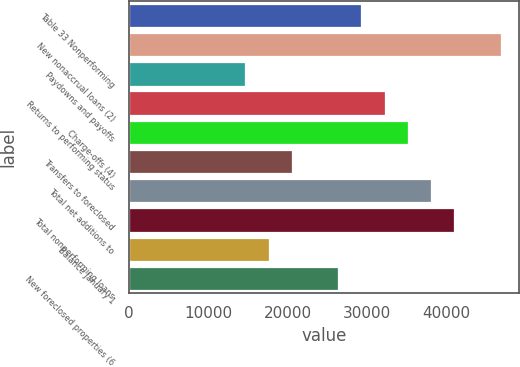Convert chart to OTSL. <chart><loc_0><loc_0><loc_500><loc_500><bar_chart><fcel>Table 33 Nonperforming<fcel>New nonaccrual loans (2)<fcel>Paydowns and payoffs<fcel>Returns to performing status<fcel>Charge-offs (4)<fcel>Transfers to foreclosed<fcel>Total net additions to<fcel>Total nonperforming loans<fcel>Balance January 1<fcel>New foreclosed properties (6<nl><fcel>29271<fcel>46831.4<fcel>14637.3<fcel>32197.8<fcel>35124.5<fcel>20490.8<fcel>38051.2<fcel>40978<fcel>17564<fcel>26344.3<nl></chart> 